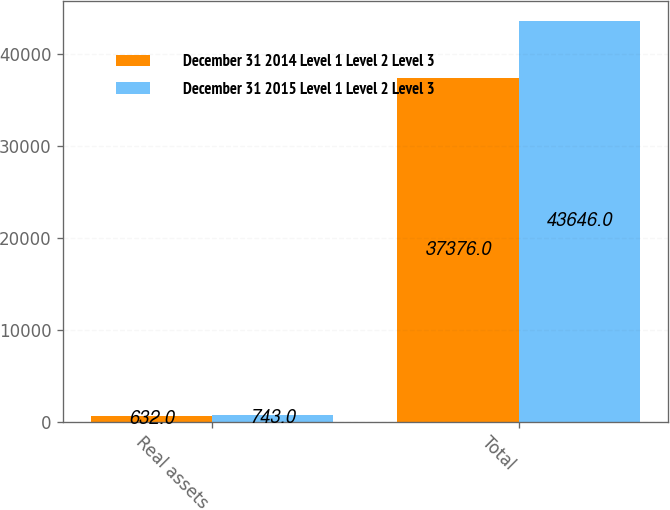Convert chart to OTSL. <chart><loc_0><loc_0><loc_500><loc_500><stacked_bar_chart><ecel><fcel>Real assets<fcel>Total<nl><fcel>December 31 2014 Level 1 Level 2 Level 3<fcel>632<fcel>37376<nl><fcel>December 31 2015 Level 1 Level 2 Level 3<fcel>743<fcel>43646<nl></chart> 